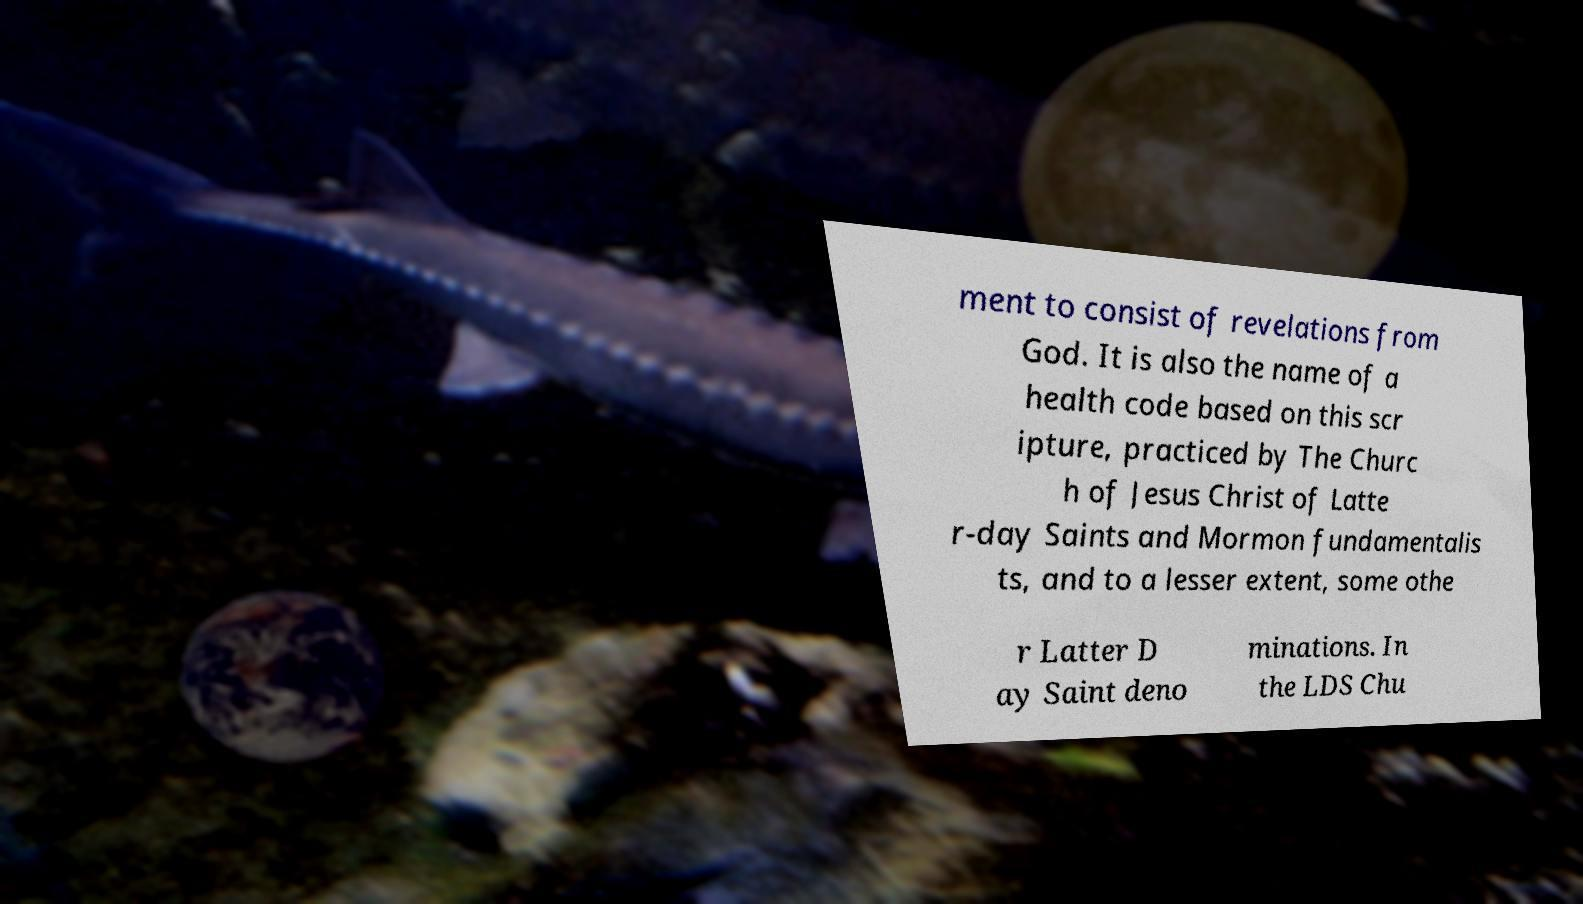There's text embedded in this image that I need extracted. Can you transcribe it verbatim? ment to consist of revelations from God. It is also the name of a health code based on this scr ipture, practiced by The Churc h of Jesus Christ of Latte r-day Saints and Mormon fundamentalis ts, and to a lesser extent, some othe r Latter D ay Saint deno minations. In the LDS Chu 